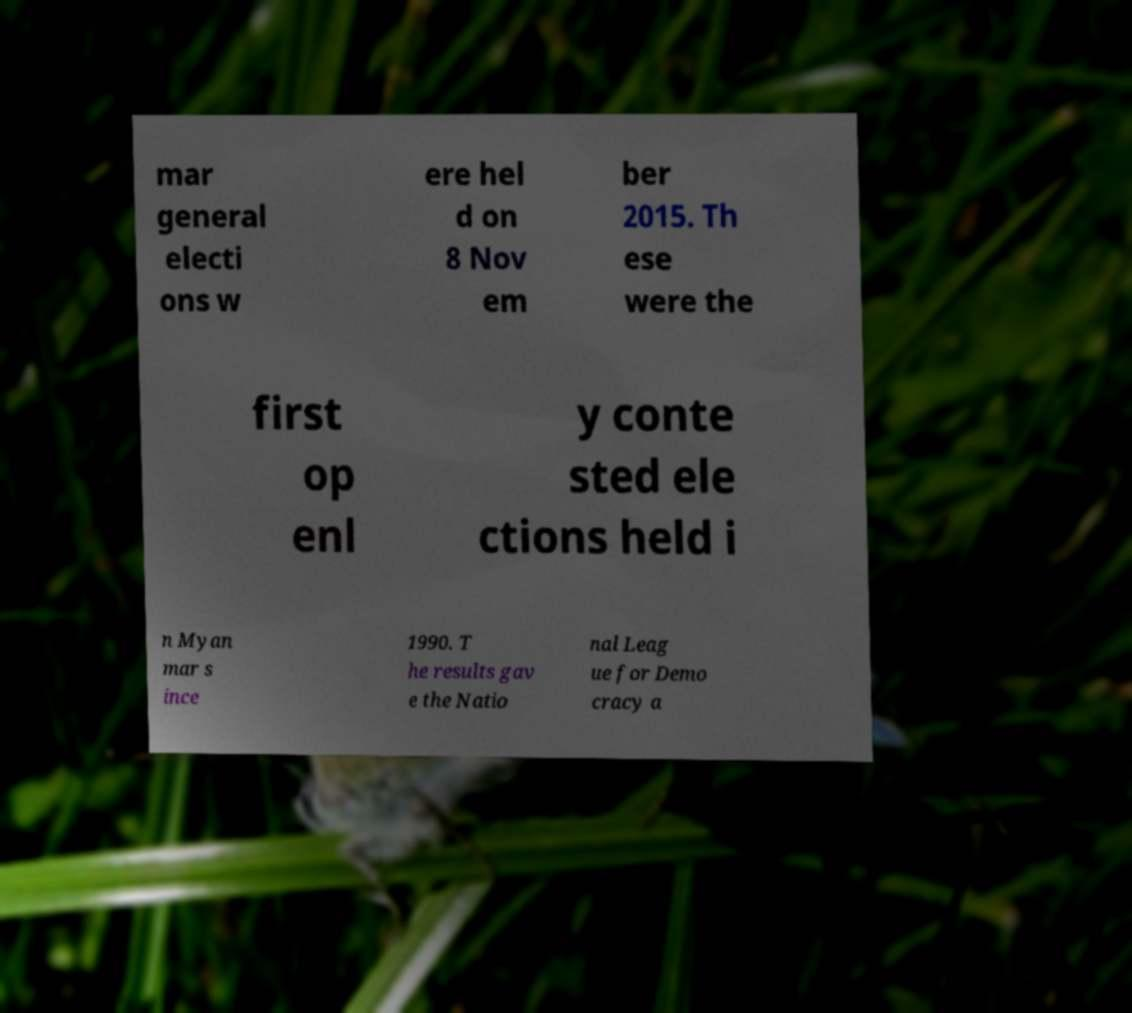Could you assist in decoding the text presented in this image and type it out clearly? mar general electi ons w ere hel d on 8 Nov em ber 2015. Th ese were the first op enl y conte sted ele ctions held i n Myan mar s ince 1990. T he results gav e the Natio nal Leag ue for Demo cracy a 